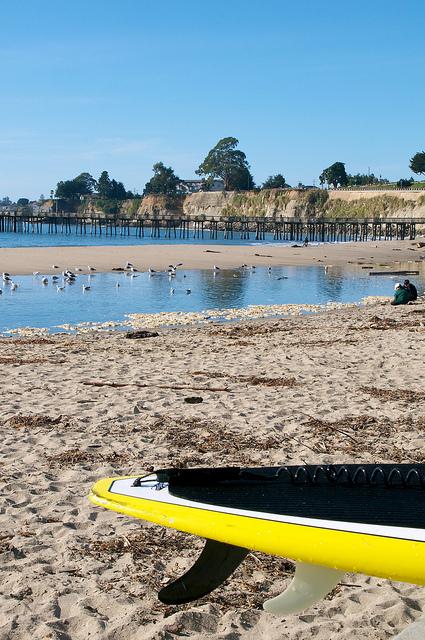What is below the surfboard?
Concise answer only. Sand. Are there birds in the water?
Answer briefly. Yes. What is this yellow and black object?
Answer briefly. Surfboard. 